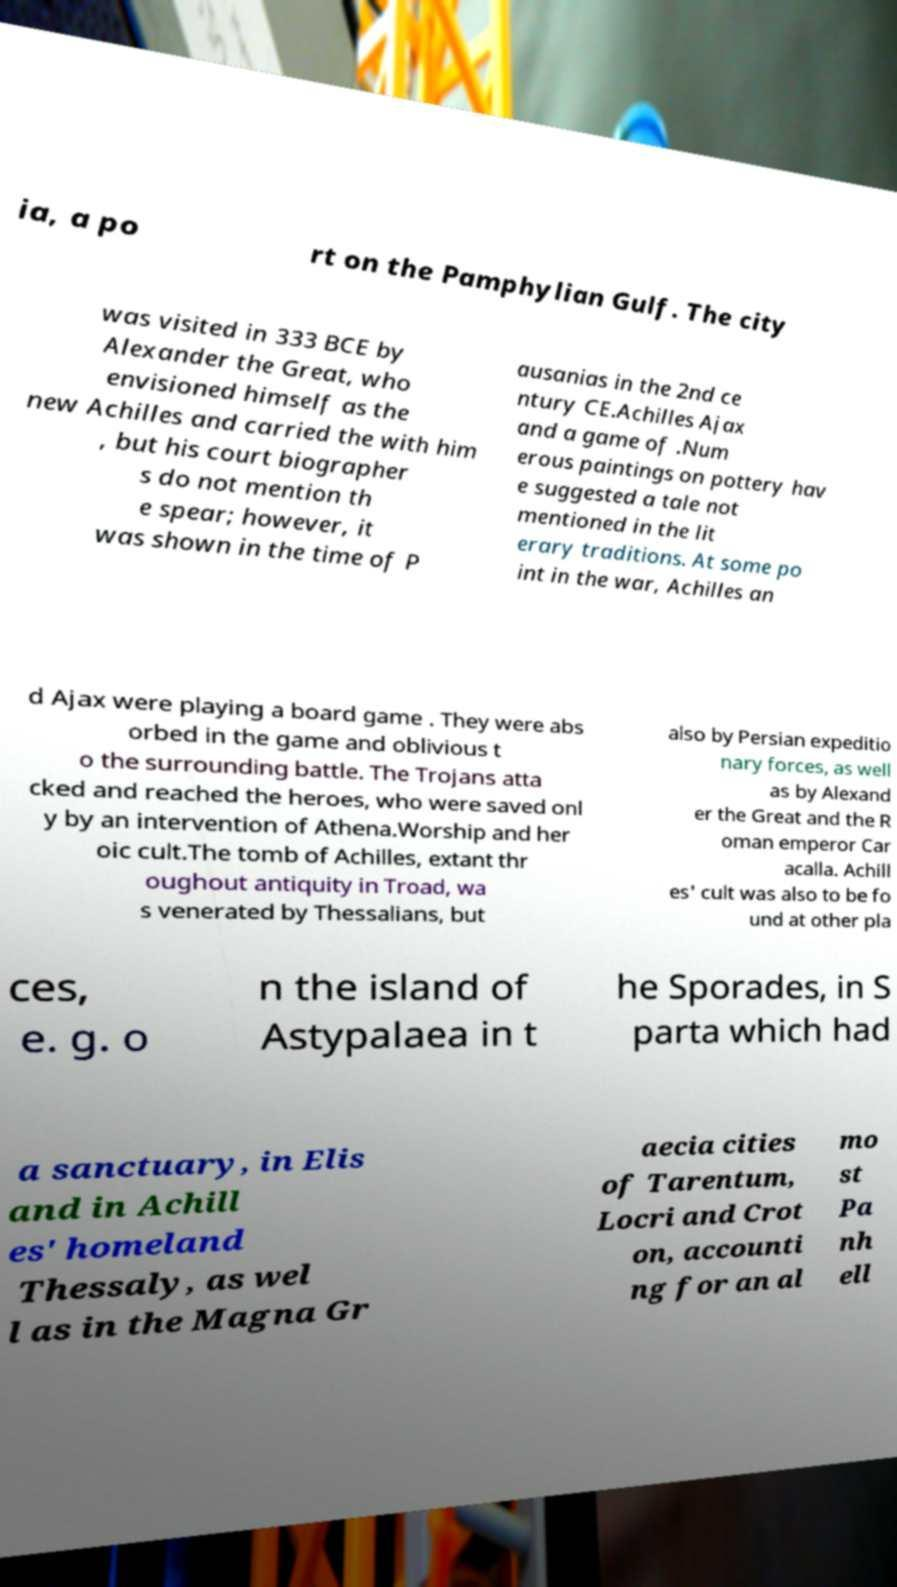I need the written content from this picture converted into text. Can you do that? ia, a po rt on the Pamphylian Gulf. The city was visited in 333 BCE by Alexander the Great, who envisioned himself as the new Achilles and carried the with him , but his court biographer s do not mention th e spear; however, it was shown in the time of P ausanias in the 2nd ce ntury CE.Achilles Ajax and a game of .Num erous paintings on pottery hav e suggested a tale not mentioned in the lit erary traditions. At some po int in the war, Achilles an d Ajax were playing a board game . They were abs orbed in the game and oblivious t o the surrounding battle. The Trojans atta cked and reached the heroes, who were saved onl y by an intervention of Athena.Worship and her oic cult.The tomb of Achilles, extant thr oughout antiquity in Troad, wa s venerated by Thessalians, but also by Persian expeditio nary forces, as well as by Alexand er the Great and the R oman emperor Car acalla. Achill es' cult was also to be fo und at other pla ces, e. g. o n the island of Astypalaea in t he Sporades, in S parta which had a sanctuary, in Elis and in Achill es' homeland Thessaly, as wel l as in the Magna Gr aecia cities of Tarentum, Locri and Crot on, accounti ng for an al mo st Pa nh ell 